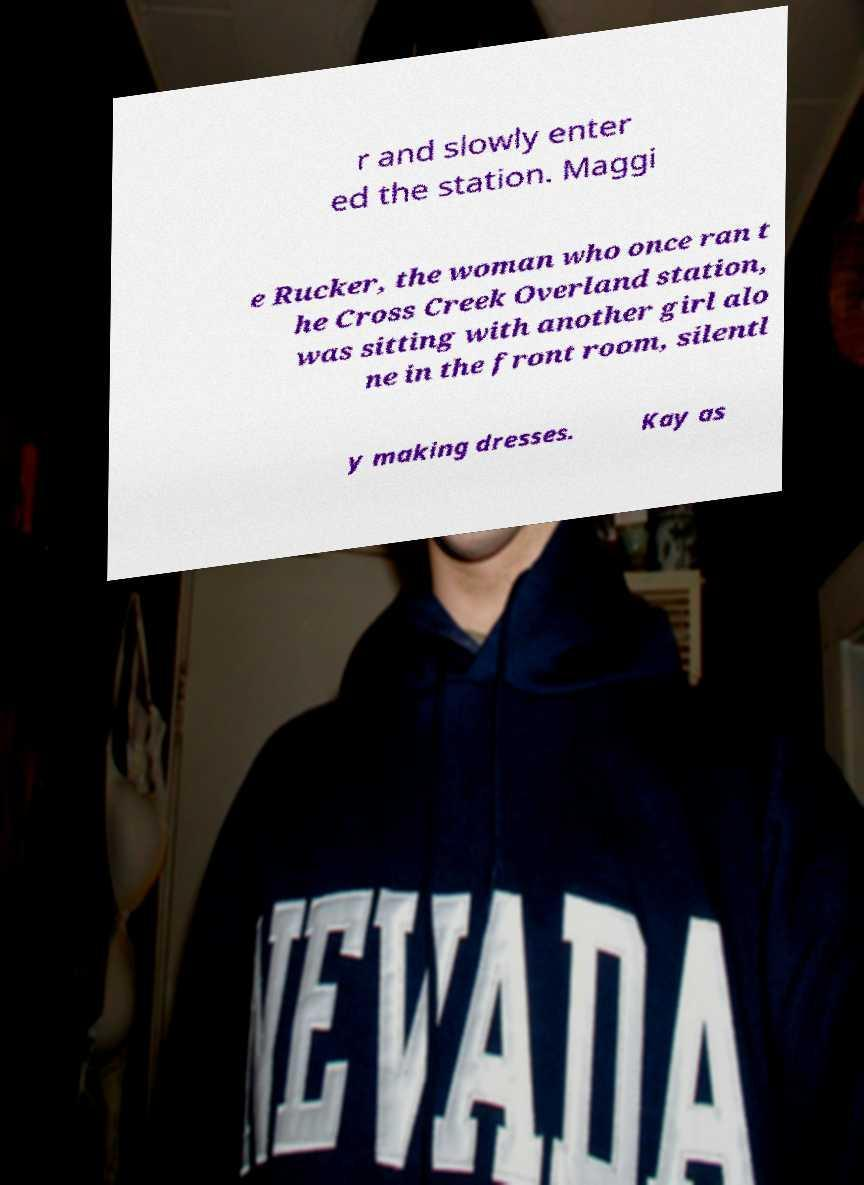There's text embedded in this image that I need extracted. Can you transcribe it verbatim? r and slowly enter ed the station. Maggi e Rucker, the woman who once ran t he Cross Creek Overland station, was sitting with another girl alo ne in the front room, silentl y making dresses. Kay as 